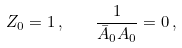<formula> <loc_0><loc_0><loc_500><loc_500>Z _ { 0 } = 1 \, , \quad \frac { 1 } { \bar { A } _ { 0 } A _ { 0 } } = 0 \, ,</formula> 